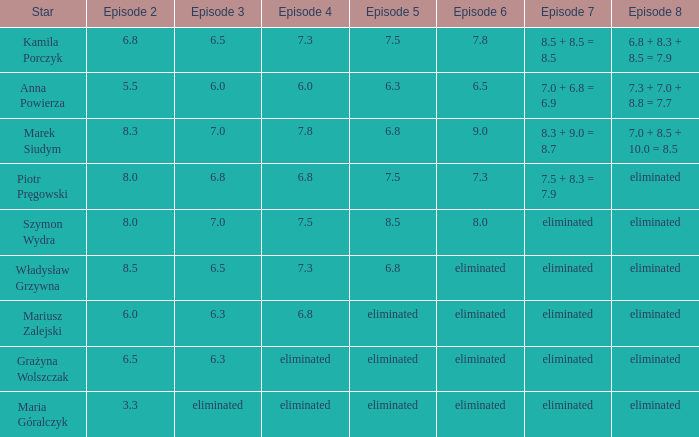Can you parse all the data within this table? {'header': ['Star', 'Episode 2', 'Episode 3', 'Episode 4', 'Episode 5', 'Episode 6', 'Episode 7', 'Episode 8'], 'rows': [['Kamila Porczyk', '6.8', '6.5', '7.3', '7.5', '7.8', '8.5 + 8.5 = 8.5', '6.8 + 8.3 + 8.5 = 7.9'], ['Anna Powierza', '5.5', '6.0', '6.0', '6.3', '6.5', '7.0 + 6.8 = 6.9', '7.3 + 7.0 + 8.8 = 7.7'], ['Marek Siudym', '8.3', '7.0', '7.8', '6.8', '9.0', '8.3 + 9.0 = 8.7', '7.0 + 8.5 + 10.0 = 8.5'], ['Piotr Pręgowski', '8.0', '6.8', '6.8', '7.5', '7.3', '7.5 + 8.3 = 7.9', 'eliminated'], ['Szymon Wydra', '8.0', '7.0', '7.5', '8.5', '8.0', 'eliminated', 'eliminated'], ['Władysław Grzywna', '8.5', '6.5', '7.3', '6.8', 'eliminated', 'eliminated', 'eliminated'], ['Mariusz Zalejski', '6.0', '6.3', '6.8', 'eliminated', 'eliminated', 'eliminated', 'eliminated'], ['Grażyna Wolszczak', '6.5', '6.3', 'eliminated', 'eliminated', 'eliminated', 'eliminated', 'eliminated'], ['Maria Góralczyk', '3.3', 'eliminated', 'eliminated', 'eliminated', 'eliminated', 'eliminated', 'eliminated']]} Which episode 4 has a Star of anna powierza? 6.0. 